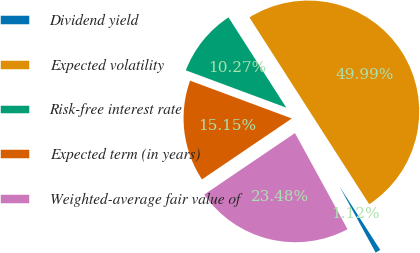<chart> <loc_0><loc_0><loc_500><loc_500><pie_chart><fcel>Dividend yield<fcel>Expected volatility<fcel>Risk-free interest rate<fcel>Expected term (in years)<fcel>Weighted-average fair value of<nl><fcel>1.12%<fcel>49.99%<fcel>10.27%<fcel>15.15%<fcel>23.48%<nl></chart> 